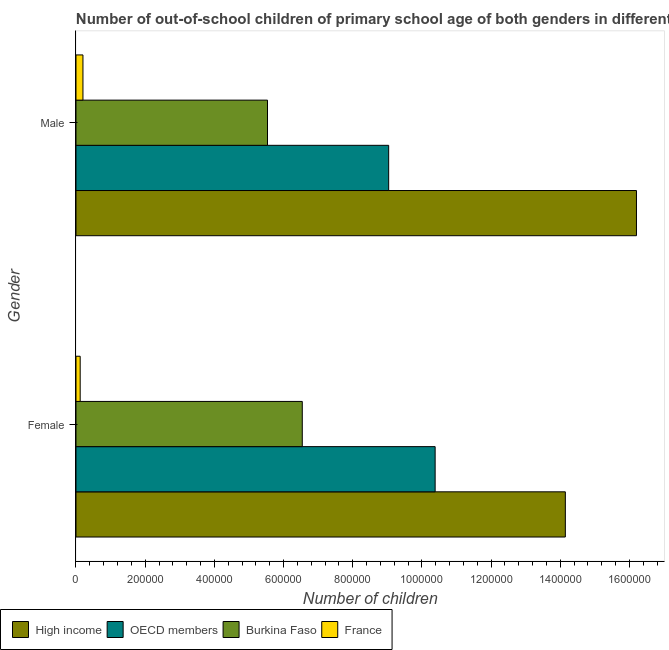How many groups of bars are there?
Keep it short and to the point. 2. Are the number of bars per tick equal to the number of legend labels?
Your answer should be very brief. Yes. How many bars are there on the 2nd tick from the top?
Provide a succinct answer. 4. How many bars are there on the 2nd tick from the bottom?
Give a very brief answer. 4. What is the number of male out-of-school students in France?
Your answer should be compact. 2.01e+04. Across all countries, what is the maximum number of female out-of-school students?
Ensure brevity in your answer.  1.41e+06. Across all countries, what is the minimum number of male out-of-school students?
Give a very brief answer. 2.01e+04. What is the total number of female out-of-school students in the graph?
Provide a short and direct response. 3.12e+06. What is the difference between the number of male out-of-school students in Burkina Faso and that in France?
Offer a terse response. 5.33e+05. What is the difference between the number of female out-of-school students in High income and the number of male out-of-school students in Burkina Faso?
Offer a very short reply. 8.61e+05. What is the average number of male out-of-school students per country?
Make the answer very short. 7.74e+05. What is the difference between the number of female out-of-school students and number of male out-of-school students in High income?
Offer a very short reply. -2.06e+05. In how many countries, is the number of female out-of-school students greater than 640000 ?
Your answer should be very brief. 3. What is the ratio of the number of male out-of-school students in High income to that in France?
Your response must be concise. 80.47. In how many countries, is the number of male out-of-school students greater than the average number of male out-of-school students taken over all countries?
Provide a short and direct response. 2. What does the 2nd bar from the top in Male represents?
Keep it short and to the point. Burkina Faso. What does the 4th bar from the bottom in Female represents?
Keep it short and to the point. France. Are all the bars in the graph horizontal?
Your answer should be compact. Yes. How many countries are there in the graph?
Provide a short and direct response. 4. What is the difference between two consecutive major ticks on the X-axis?
Offer a very short reply. 2.00e+05. Are the values on the major ticks of X-axis written in scientific E-notation?
Your response must be concise. No. Does the graph contain any zero values?
Offer a terse response. No. Does the graph contain grids?
Offer a terse response. No. Where does the legend appear in the graph?
Your answer should be compact. Bottom left. What is the title of the graph?
Offer a very short reply. Number of out-of-school children of primary school age of both genders in different countries. Does "Aruba" appear as one of the legend labels in the graph?
Provide a succinct answer. No. What is the label or title of the X-axis?
Give a very brief answer. Number of children. What is the Number of children of High income in Female?
Offer a very short reply. 1.41e+06. What is the Number of children of OECD members in Female?
Provide a succinct answer. 1.04e+06. What is the Number of children in Burkina Faso in Female?
Ensure brevity in your answer.  6.54e+05. What is the Number of children of France in Female?
Keep it short and to the point. 1.21e+04. What is the Number of children of High income in Male?
Provide a short and direct response. 1.62e+06. What is the Number of children of OECD members in Male?
Offer a very short reply. 9.04e+05. What is the Number of children of Burkina Faso in Male?
Provide a succinct answer. 5.54e+05. What is the Number of children of France in Male?
Offer a very short reply. 2.01e+04. Across all Gender, what is the maximum Number of children in High income?
Provide a succinct answer. 1.62e+06. Across all Gender, what is the maximum Number of children in OECD members?
Offer a terse response. 1.04e+06. Across all Gender, what is the maximum Number of children in Burkina Faso?
Give a very brief answer. 6.54e+05. Across all Gender, what is the maximum Number of children of France?
Keep it short and to the point. 2.01e+04. Across all Gender, what is the minimum Number of children of High income?
Offer a very short reply. 1.41e+06. Across all Gender, what is the minimum Number of children in OECD members?
Keep it short and to the point. 9.04e+05. Across all Gender, what is the minimum Number of children in Burkina Faso?
Provide a succinct answer. 5.54e+05. Across all Gender, what is the minimum Number of children of France?
Make the answer very short. 1.21e+04. What is the total Number of children of High income in the graph?
Provide a short and direct response. 3.03e+06. What is the total Number of children of OECD members in the graph?
Your answer should be very brief. 1.94e+06. What is the total Number of children in Burkina Faso in the graph?
Your response must be concise. 1.21e+06. What is the total Number of children in France in the graph?
Give a very brief answer. 3.23e+04. What is the difference between the Number of children of High income in Female and that in Male?
Your answer should be very brief. -2.06e+05. What is the difference between the Number of children in OECD members in Female and that in Male?
Provide a short and direct response. 1.34e+05. What is the difference between the Number of children of Burkina Faso in Female and that in Male?
Offer a terse response. 1.01e+05. What is the difference between the Number of children of France in Female and that in Male?
Give a very brief answer. -8015. What is the difference between the Number of children of High income in Female and the Number of children of OECD members in Male?
Your answer should be compact. 5.11e+05. What is the difference between the Number of children of High income in Female and the Number of children of Burkina Faso in Male?
Your answer should be very brief. 8.61e+05. What is the difference between the Number of children in High income in Female and the Number of children in France in Male?
Give a very brief answer. 1.39e+06. What is the difference between the Number of children in OECD members in Female and the Number of children in Burkina Faso in Male?
Provide a succinct answer. 4.85e+05. What is the difference between the Number of children of OECD members in Female and the Number of children of France in Male?
Give a very brief answer. 1.02e+06. What is the difference between the Number of children of Burkina Faso in Female and the Number of children of France in Male?
Ensure brevity in your answer.  6.34e+05. What is the average Number of children in High income per Gender?
Make the answer very short. 1.52e+06. What is the average Number of children of OECD members per Gender?
Offer a very short reply. 9.71e+05. What is the average Number of children in Burkina Faso per Gender?
Offer a terse response. 6.04e+05. What is the average Number of children of France per Gender?
Your answer should be compact. 1.61e+04. What is the difference between the Number of children in High income and Number of children in OECD members in Female?
Make the answer very short. 3.76e+05. What is the difference between the Number of children in High income and Number of children in Burkina Faso in Female?
Your response must be concise. 7.60e+05. What is the difference between the Number of children of High income and Number of children of France in Female?
Provide a short and direct response. 1.40e+06. What is the difference between the Number of children of OECD members and Number of children of Burkina Faso in Female?
Offer a terse response. 3.84e+05. What is the difference between the Number of children in OECD members and Number of children in France in Female?
Your response must be concise. 1.03e+06. What is the difference between the Number of children in Burkina Faso and Number of children in France in Female?
Make the answer very short. 6.42e+05. What is the difference between the Number of children of High income and Number of children of OECD members in Male?
Make the answer very short. 7.16e+05. What is the difference between the Number of children of High income and Number of children of Burkina Faso in Male?
Make the answer very short. 1.07e+06. What is the difference between the Number of children of High income and Number of children of France in Male?
Your response must be concise. 1.60e+06. What is the difference between the Number of children of OECD members and Number of children of Burkina Faso in Male?
Provide a short and direct response. 3.50e+05. What is the difference between the Number of children in OECD members and Number of children in France in Male?
Give a very brief answer. 8.84e+05. What is the difference between the Number of children in Burkina Faso and Number of children in France in Male?
Offer a very short reply. 5.33e+05. What is the ratio of the Number of children of High income in Female to that in Male?
Provide a succinct answer. 0.87. What is the ratio of the Number of children in OECD members in Female to that in Male?
Provide a succinct answer. 1.15. What is the ratio of the Number of children of Burkina Faso in Female to that in Male?
Make the answer very short. 1.18. What is the ratio of the Number of children in France in Female to that in Male?
Your response must be concise. 0.6. What is the difference between the highest and the second highest Number of children in High income?
Ensure brevity in your answer.  2.06e+05. What is the difference between the highest and the second highest Number of children in OECD members?
Make the answer very short. 1.34e+05. What is the difference between the highest and the second highest Number of children of Burkina Faso?
Your answer should be very brief. 1.01e+05. What is the difference between the highest and the second highest Number of children in France?
Your answer should be very brief. 8015. What is the difference between the highest and the lowest Number of children of High income?
Your answer should be very brief. 2.06e+05. What is the difference between the highest and the lowest Number of children in OECD members?
Your response must be concise. 1.34e+05. What is the difference between the highest and the lowest Number of children of Burkina Faso?
Your answer should be very brief. 1.01e+05. What is the difference between the highest and the lowest Number of children of France?
Your answer should be very brief. 8015. 